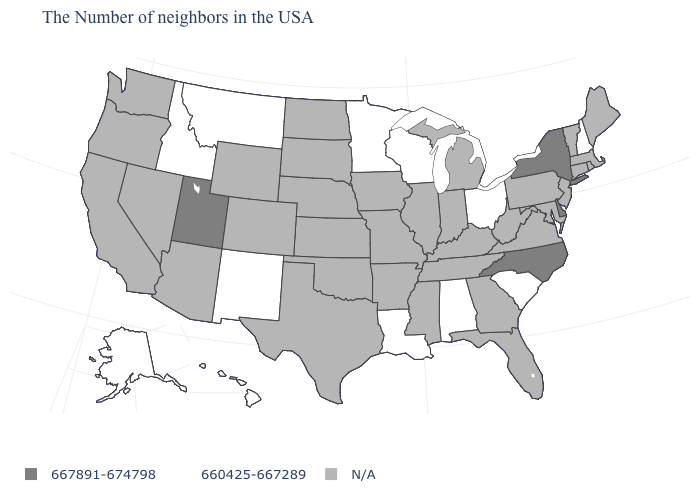Among the states that border Mississippi , which have the lowest value?
Keep it brief. Alabama, Louisiana. Is the legend a continuous bar?
Answer briefly. No. Which states hav the highest value in the South?
Be succinct. Delaware, North Carolina. Which states have the highest value in the USA?
Answer briefly. New York, Delaware, North Carolina, Utah. What is the lowest value in the USA?
Quick response, please. 660425-667289. Is the legend a continuous bar?
Concise answer only. No. Does Delaware have the highest value in the USA?
Concise answer only. Yes. Name the states that have a value in the range 660425-667289?
Be succinct. New Hampshire, South Carolina, Ohio, Alabama, Wisconsin, Louisiana, Minnesota, New Mexico, Montana, Idaho, Alaska, Hawaii. Which states hav the highest value in the MidWest?
Answer briefly. Ohio, Wisconsin, Minnesota. Which states have the highest value in the USA?
Give a very brief answer. New York, Delaware, North Carolina, Utah. What is the value of South Dakota?
Keep it brief. N/A. Name the states that have a value in the range 667891-674798?
Answer briefly. New York, Delaware, North Carolina, Utah. What is the value of North Dakota?
Concise answer only. N/A. What is the value of New York?
Give a very brief answer. 667891-674798. 